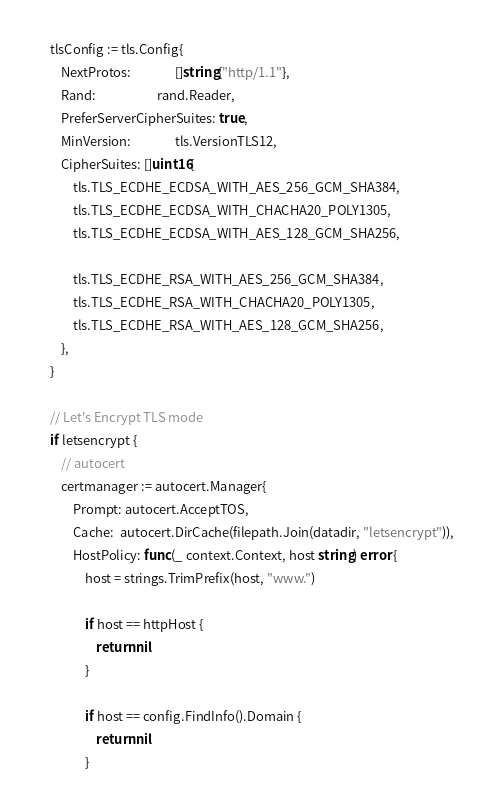<code> <loc_0><loc_0><loc_500><loc_500><_Go_>	tlsConfig := tls.Config{
		NextProtos:               []string{"http/1.1"},
		Rand:                     rand.Reader,
		PreferServerCipherSuites: true,
		MinVersion:               tls.VersionTLS12,
		CipherSuites: []uint16{
			tls.TLS_ECDHE_ECDSA_WITH_AES_256_GCM_SHA384,
			tls.TLS_ECDHE_ECDSA_WITH_CHACHA20_POLY1305,
			tls.TLS_ECDHE_ECDSA_WITH_AES_128_GCM_SHA256,

			tls.TLS_ECDHE_RSA_WITH_AES_256_GCM_SHA384,
			tls.TLS_ECDHE_RSA_WITH_CHACHA20_POLY1305,
			tls.TLS_ECDHE_RSA_WITH_AES_128_GCM_SHA256,
		},
	}

	// Let's Encrypt TLS mode
	if letsencrypt {
		// autocert
		certmanager := autocert.Manager{
			Prompt: autocert.AcceptTOS,
			Cache:  autocert.DirCache(filepath.Join(datadir, "letsencrypt")),
			HostPolicy: func(_ context.Context, host string) error {
				host = strings.TrimPrefix(host, "www.")

				if host == httpHost {
					return nil
				}

				if host == config.FindInfo().Domain {
					return nil
				}</code> 